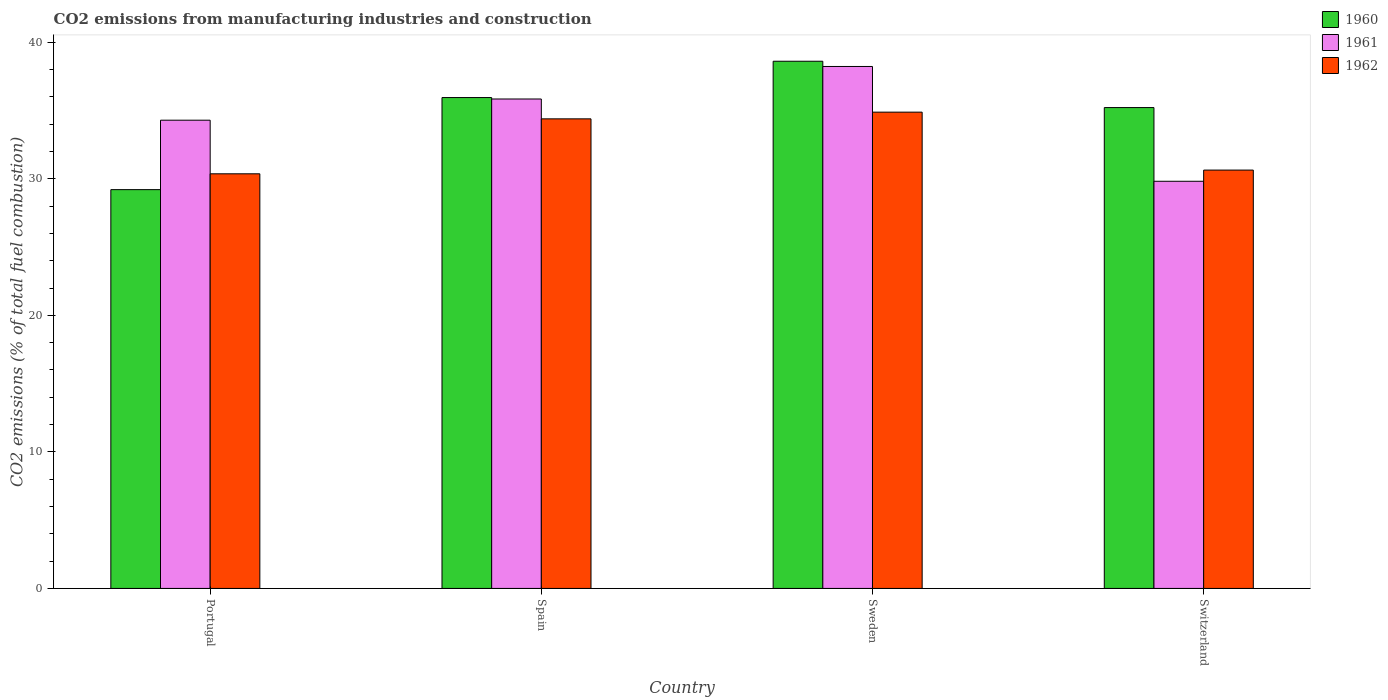Are the number of bars per tick equal to the number of legend labels?
Your response must be concise. Yes. How many bars are there on the 2nd tick from the right?
Keep it short and to the point. 3. In how many cases, is the number of bars for a given country not equal to the number of legend labels?
Provide a succinct answer. 0. What is the amount of CO2 emitted in 1960 in Portugal?
Your answer should be compact. 29.21. Across all countries, what is the maximum amount of CO2 emitted in 1960?
Keep it short and to the point. 38.61. Across all countries, what is the minimum amount of CO2 emitted in 1962?
Make the answer very short. 30.37. In which country was the amount of CO2 emitted in 1962 maximum?
Make the answer very short. Sweden. In which country was the amount of CO2 emitted in 1961 minimum?
Offer a terse response. Switzerland. What is the total amount of CO2 emitted in 1962 in the graph?
Ensure brevity in your answer.  130.28. What is the difference between the amount of CO2 emitted in 1962 in Portugal and that in Sweden?
Provide a succinct answer. -4.52. What is the difference between the amount of CO2 emitted in 1962 in Spain and the amount of CO2 emitted in 1961 in Portugal?
Your answer should be very brief. 0.1. What is the average amount of CO2 emitted in 1960 per country?
Offer a terse response. 34.75. What is the difference between the amount of CO2 emitted of/in 1962 and amount of CO2 emitted of/in 1960 in Switzerland?
Keep it short and to the point. -4.58. In how many countries, is the amount of CO2 emitted in 1961 greater than 12 %?
Your answer should be compact. 4. What is the ratio of the amount of CO2 emitted in 1961 in Portugal to that in Sweden?
Keep it short and to the point. 0.9. What is the difference between the highest and the second highest amount of CO2 emitted in 1961?
Your answer should be compact. -1.55. What is the difference between the highest and the lowest amount of CO2 emitted in 1961?
Offer a very short reply. 8.41. Is the sum of the amount of CO2 emitted in 1960 in Spain and Switzerland greater than the maximum amount of CO2 emitted in 1961 across all countries?
Offer a terse response. Yes. How many bars are there?
Offer a terse response. 12. Are all the bars in the graph horizontal?
Offer a very short reply. No. What is the difference between two consecutive major ticks on the Y-axis?
Provide a short and direct response. 10. Does the graph contain any zero values?
Your response must be concise. No. Where does the legend appear in the graph?
Your response must be concise. Top right. How many legend labels are there?
Keep it short and to the point. 3. What is the title of the graph?
Provide a succinct answer. CO2 emissions from manufacturing industries and construction. What is the label or title of the Y-axis?
Provide a short and direct response. CO2 emissions (% of total fuel combustion). What is the CO2 emissions (% of total fuel combustion) of 1960 in Portugal?
Give a very brief answer. 29.21. What is the CO2 emissions (% of total fuel combustion) in 1961 in Portugal?
Provide a short and direct response. 34.29. What is the CO2 emissions (% of total fuel combustion) of 1962 in Portugal?
Your answer should be compact. 30.37. What is the CO2 emissions (% of total fuel combustion) in 1960 in Spain?
Provide a short and direct response. 35.95. What is the CO2 emissions (% of total fuel combustion) of 1961 in Spain?
Provide a succinct answer. 35.85. What is the CO2 emissions (% of total fuel combustion) in 1962 in Spain?
Provide a succinct answer. 34.39. What is the CO2 emissions (% of total fuel combustion) of 1960 in Sweden?
Give a very brief answer. 38.61. What is the CO2 emissions (% of total fuel combustion) of 1961 in Sweden?
Provide a short and direct response. 38.23. What is the CO2 emissions (% of total fuel combustion) in 1962 in Sweden?
Offer a very short reply. 34.88. What is the CO2 emissions (% of total fuel combustion) in 1960 in Switzerland?
Give a very brief answer. 35.22. What is the CO2 emissions (% of total fuel combustion) in 1961 in Switzerland?
Your answer should be very brief. 29.82. What is the CO2 emissions (% of total fuel combustion) of 1962 in Switzerland?
Your response must be concise. 30.64. Across all countries, what is the maximum CO2 emissions (% of total fuel combustion) of 1960?
Offer a very short reply. 38.61. Across all countries, what is the maximum CO2 emissions (% of total fuel combustion) in 1961?
Offer a terse response. 38.23. Across all countries, what is the maximum CO2 emissions (% of total fuel combustion) in 1962?
Ensure brevity in your answer.  34.88. Across all countries, what is the minimum CO2 emissions (% of total fuel combustion) in 1960?
Your answer should be very brief. 29.21. Across all countries, what is the minimum CO2 emissions (% of total fuel combustion) of 1961?
Provide a short and direct response. 29.82. Across all countries, what is the minimum CO2 emissions (% of total fuel combustion) in 1962?
Provide a succinct answer. 30.37. What is the total CO2 emissions (% of total fuel combustion) of 1960 in the graph?
Offer a very short reply. 138.99. What is the total CO2 emissions (% of total fuel combustion) of 1961 in the graph?
Give a very brief answer. 138.19. What is the total CO2 emissions (% of total fuel combustion) in 1962 in the graph?
Offer a very short reply. 130.28. What is the difference between the CO2 emissions (% of total fuel combustion) in 1960 in Portugal and that in Spain?
Offer a terse response. -6.74. What is the difference between the CO2 emissions (% of total fuel combustion) in 1961 in Portugal and that in Spain?
Keep it short and to the point. -1.55. What is the difference between the CO2 emissions (% of total fuel combustion) of 1962 in Portugal and that in Spain?
Your answer should be compact. -4.03. What is the difference between the CO2 emissions (% of total fuel combustion) of 1960 in Portugal and that in Sweden?
Your answer should be compact. -9.4. What is the difference between the CO2 emissions (% of total fuel combustion) of 1961 in Portugal and that in Sweden?
Keep it short and to the point. -3.93. What is the difference between the CO2 emissions (% of total fuel combustion) in 1962 in Portugal and that in Sweden?
Your answer should be compact. -4.52. What is the difference between the CO2 emissions (% of total fuel combustion) in 1960 in Portugal and that in Switzerland?
Your response must be concise. -6.01. What is the difference between the CO2 emissions (% of total fuel combustion) of 1961 in Portugal and that in Switzerland?
Offer a very short reply. 4.47. What is the difference between the CO2 emissions (% of total fuel combustion) of 1962 in Portugal and that in Switzerland?
Provide a succinct answer. -0.27. What is the difference between the CO2 emissions (% of total fuel combustion) of 1960 in Spain and that in Sweden?
Offer a terse response. -2.66. What is the difference between the CO2 emissions (% of total fuel combustion) in 1961 in Spain and that in Sweden?
Make the answer very short. -2.38. What is the difference between the CO2 emissions (% of total fuel combustion) in 1962 in Spain and that in Sweden?
Keep it short and to the point. -0.49. What is the difference between the CO2 emissions (% of total fuel combustion) of 1960 in Spain and that in Switzerland?
Offer a very short reply. 0.73. What is the difference between the CO2 emissions (% of total fuel combustion) in 1961 in Spain and that in Switzerland?
Your answer should be very brief. 6.03. What is the difference between the CO2 emissions (% of total fuel combustion) of 1962 in Spain and that in Switzerland?
Give a very brief answer. 3.75. What is the difference between the CO2 emissions (% of total fuel combustion) of 1960 in Sweden and that in Switzerland?
Offer a very short reply. 3.39. What is the difference between the CO2 emissions (% of total fuel combustion) of 1961 in Sweden and that in Switzerland?
Make the answer very short. 8.41. What is the difference between the CO2 emissions (% of total fuel combustion) in 1962 in Sweden and that in Switzerland?
Your answer should be compact. 4.24. What is the difference between the CO2 emissions (% of total fuel combustion) in 1960 in Portugal and the CO2 emissions (% of total fuel combustion) in 1961 in Spain?
Keep it short and to the point. -6.64. What is the difference between the CO2 emissions (% of total fuel combustion) in 1960 in Portugal and the CO2 emissions (% of total fuel combustion) in 1962 in Spain?
Make the answer very short. -5.18. What is the difference between the CO2 emissions (% of total fuel combustion) of 1961 in Portugal and the CO2 emissions (% of total fuel combustion) of 1962 in Spain?
Your response must be concise. -0.1. What is the difference between the CO2 emissions (% of total fuel combustion) of 1960 in Portugal and the CO2 emissions (% of total fuel combustion) of 1961 in Sweden?
Your answer should be compact. -9.02. What is the difference between the CO2 emissions (% of total fuel combustion) in 1960 in Portugal and the CO2 emissions (% of total fuel combustion) in 1962 in Sweden?
Ensure brevity in your answer.  -5.68. What is the difference between the CO2 emissions (% of total fuel combustion) in 1961 in Portugal and the CO2 emissions (% of total fuel combustion) in 1962 in Sweden?
Your answer should be very brief. -0.59. What is the difference between the CO2 emissions (% of total fuel combustion) in 1960 in Portugal and the CO2 emissions (% of total fuel combustion) in 1961 in Switzerland?
Provide a short and direct response. -0.61. What is the difference between the CO2 emissions (% of total fuel combustion) of 1960 in Portugal and the CO2 emissions (% of total fuel combustion) of 1962 in Switzerland?
Your answer should be compact. -1.43. What is the difference between the CO2 emissions (% of total fuel combustion) of 1961 in Portugal and the CO2 emissions (% of total fuel combustion) of 1962 in Switzerland?
Your response must be concise. 3.65. What is the difference between the CO2 emissions (% of total fuel combustion) in 1960 in Spain and the CO2 emissions (% of total fuel combustion) in 1961 in Sweden?
Give a very brief answer. -2.28. What is the difference between the CO2 emissions (% of total fuel combustion) of 1960 in Spain and the CO2 emissions (% of total fuel combustion) of 1962 in Sweden?
Your answer should be compact. 1.07. What is the difference between the CO2 emissions (% of total fuel combustion) in 1961 in Spain and the CO2 emissions (% of total fuel combustion) in 1962 in Sweden?
Offer a very short reply. 0.96. What is the difference between the CO2 emissions (% of total fuel combustion) of 1960 in Spain and the CO2 emissions (% of total fuel combustion) of 1961 in Switzerland?
Your answer should be very brief. 6.13. What is the difference between the CO2 emissions (% of total fuel combustion) in 1960 in Spain and the CO2 emissions (% of total fuel combustion) in 1962 in Switzerland?
Give a very brief answer. 5.31. What is the difference between the CO2 emissions (% of total fuel combustion) of 1961 in Spain and the CO2 emissions (% of total fuel combustion) of 1962 in Switzerland?
Offer a terse response. 5.21. What is the difference between the CO2 emissions (% of total fuel combustion) of 1960 in Sweden and the CO2 emissions (% of total fuel combustion) of 1961 in Switzerland?
Ensure brevity in your answer.  8.79. What is the difference between the CO2 emissions (% of total fuel combustion) of 1960 in Sweden and the CO2 emissions (% of total fuel combustion) of 1962 in Switzerland?
Provide a short and direct response. 7.97. What is the difference between the CO2 emissions (% of total fuel combustion) in 1961 in Sweden and the CO2 emissions (% of total fuel combustion) in 1962 in Switzerland?
Make the answer very short. 7.59. What is the average CO2 emissions (% of total fuel combustion) in 1960 per country?
Your answer should be very brief. 34.75. What is the average CO2 emissions (% of total fuel combustion) of 1961 per country?
Offer a very short reply. 34.55. What is the average CO2 emissions (% of total fuel combustion) of 1962 per country?
Keep it short and to the point. 32.57. What is the difference between the CO2 emissions (% of total fuel combustion) in 1960 and CO2 emissions (% of total fuel combustion) in 1961 in Portugal?
Offer a terse response. -5.09. What is the difference between the CO2 emissions (% of total fuel combustion) of 1960 and CO2 emissions (% of total fuel combustion) of 1962 in Portugal?
Offer a terse response. -1.16. What is the difference between the CO2 emissions (% of total fuel combustion) of 1961 and CO2 emissions (% of total fuel combustion) of 1962 in Portugal?
Offer a very short reply. 3.93. What is the difference between the CO2 emissions (% of total fuel combustion) of 1960 and CO2 emissions (% of total fuel combustion) of 1961 in Spain?
Provide a short and direct response. 0.1. What is the difference between the CO2 emissions (% of total fuel combustion) of 1960 and CO2 emissions (% of total fuel combustion) of 1962 in Spain?
Your answer should be compact. 1.56. What is the difference between the CO2 emissions (% of total fuel combustion) of 1961 and CO2 emissions (% of total fuel combustion) of 1962 in Spain?
Offer a very short reply. 1.45. What is the difference between the CO2 emissions (% of total fuel combustion) of 1960 and CO2 emissions (% of total fuel combustion) of 1961 in Sweden?
Your response must be concise. 0.38. What is the difference between the CO2 emissions (% of total fuel combustion) in 1960 and CO2 emissions (% of total fuel combustion) in 1962 in Sweden?
Offer a terse response. 3.73. What is the difference between the CO2 emissions (% of total fuel combustion) in 1961 and CO2 emissions (% of total fuel combustion) in 1962 in Sweden?
Keep it short and to the point. 3.35. What is the difference between the CO2 emissions (% of total fuel combustion) of 1960 and CO2 emissions (% of total fuel combustion) of 1961 in Switzerland?
Provide a short and direct response. 5.4. What is the difference between the CO2 emissions (% of total fuel combustion) in 1960 and CO2 emissions (% of total fuel combustion) in 1962 in Switzerland?
Keep it short and to the point. 4.58. What is the difference between the CO2 emissions (% of total fuel combustion) of 1961 and CO2 emissions (% of total fuel combustion) of 1962 in Switzerland?
Keep it short and to the point. -0.82. What is the ratio of the CO2 emissions (% of total fuel combustion) in 1960 in Portugal to that in Spain?
Your answer should be very brief. 0.81. What is the ratio of the CO2 emissions (% of total fuel combustion) in 1961 in Portugal to that in Spain?
Your response must be concise. 0.96. What is the ratio of the CO2 emissions (% of total fuel combustion) of 1962 in Portugal to that in Spain?
Provide a short and direct response. 0.88. What is the ratio of the CO2 emissions (% of total fuel combustion) of 1960 in Portugal to that in Sweden?
Give a very brief answer. 0.76. What is the ratio of the CO2 emissions (% of total fuel combustion) of 1961 in Portugal to that in Sweden?
Your answer should be very brief. 0.9. What is the ratio of the CO2 emissions (% of total fuel combustion) of 1962 in Portugal to that in Sweden?
Keep it short and to the point. 0.87. What is the ratio of the CO2 emissions (% of total fuel combustion) in 1960 in Portugal to that in Switzerland?
Keep it short and to the point. 0.83. What is the ratio of the CO2 emissions (% of total fuel combustion) in 1961 in Portugal to that in Switzerland?
Your response must be concise. 1.15. What is the ratio of the CO2 emissions (% of total fuel combustion) in 1962 in Portugal to that in Switzerland?
Offer a terse response. 0.99. What is the ratio of the CO2 emissions (% of total fuel combustion) of 1960 in Spain to that in Sweden?
Offer a very short reply. 0.93. What is the ratio of the CO2 emissions (% of total fuel combustion) of 1961 in Spain to that in Sweden?
Provide a succinct answer. 0.94. What is the ratio of the CO2 emissions (% of total fuel combustion) of 1962 in Spain to that in Sweden?
Keep it short and to the point. 0.99. What is the ratio of the CO2 emissions (% of total fuel combustion) of 1960 in Spain to that in Switzerland?
Offer a terse response. 1.02. What is the ratio of the CO2 emissions (% of total fuel combustion) of 1961 in Spain to that in Switzerland?
Offer a terse response. 1.2. What is the ratio of the CO2 emissions (% of total fuel combustion) in 1962 in Spain to that in Switzerland?
Your answer should be compact. 1.12. What is the ratio of the CO2 emissions (% of total fuel combustion) in 1960 in Sweden to that in Switzerland?
Offer a very short reply. 1.1. What is the ratio of the CO2 emissions (% of total fuel combustion) in 1961 in Sweden to that in Switzerland?
Ensure brevity in your answer.  1.28. What is the ratio of the CO2 emissions (% of total fuel combustion) of 1962 in Sweden to that in Switzerland?
Your response must be concise. 1.14. What is the difference between the highest and the second highest CO2 emissions (% of total fuel combustion) of 1960?
Provide a succinct answer. 2.66. What is the difference between the highest and the second highest CO2 emissions (% of total fuel combustion) of 1961?
Provide a succinct answer. 2.38. What is the difference between the highest and the second highest CO2 emissions (% of total fuel combustion) in 1962?
Give a very brief answer. 0.49. What is the difference between the highest and the lowest CO2 emissions (% of total fuel combustion) of 1960?
Your response must be concise. 9.4. What is the difference between the highest and the lowest CO2 emissions (% of total fuel combustion) of 1961?
Ensure brevity in your answer.  8.41. What is the difference between the highest and the lowest CO2 emissions (% of total fuel combustion) of 1962?
Ensure brevity in your answer.  4.52. 